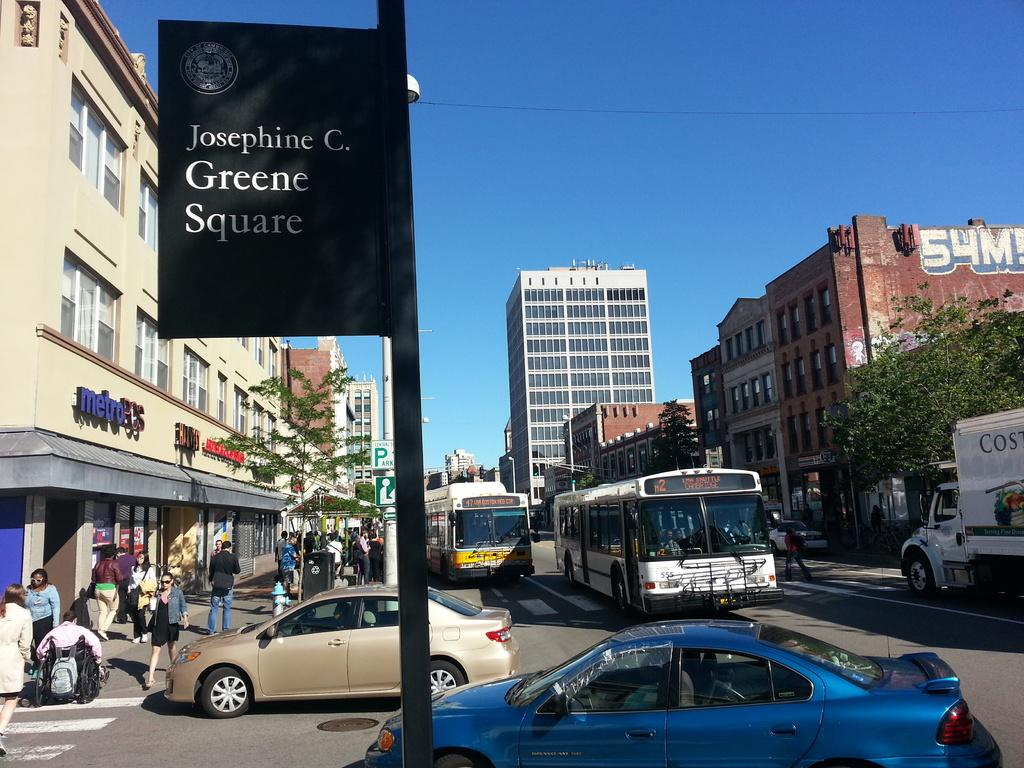What can be seen on the road in the image? There are vehicles and people on the road in the image. What structures are visible in the image? There are buildings visible in the image. What type of vegetation can be seen in the image? There are trees in the image. What objects are present in the image that might be used for displaying information or advertisements? There are boards in the image. What is visible in the background of the image? The sky is visible in the background of the image. Can you tell me where the vein is located in the image? There is no vein present in the image; it is a scene featuring vehicles, people, buildings, trees, boards, and the sky. Is there a volcano visible in the image? No, there is no volcano present in the image. 